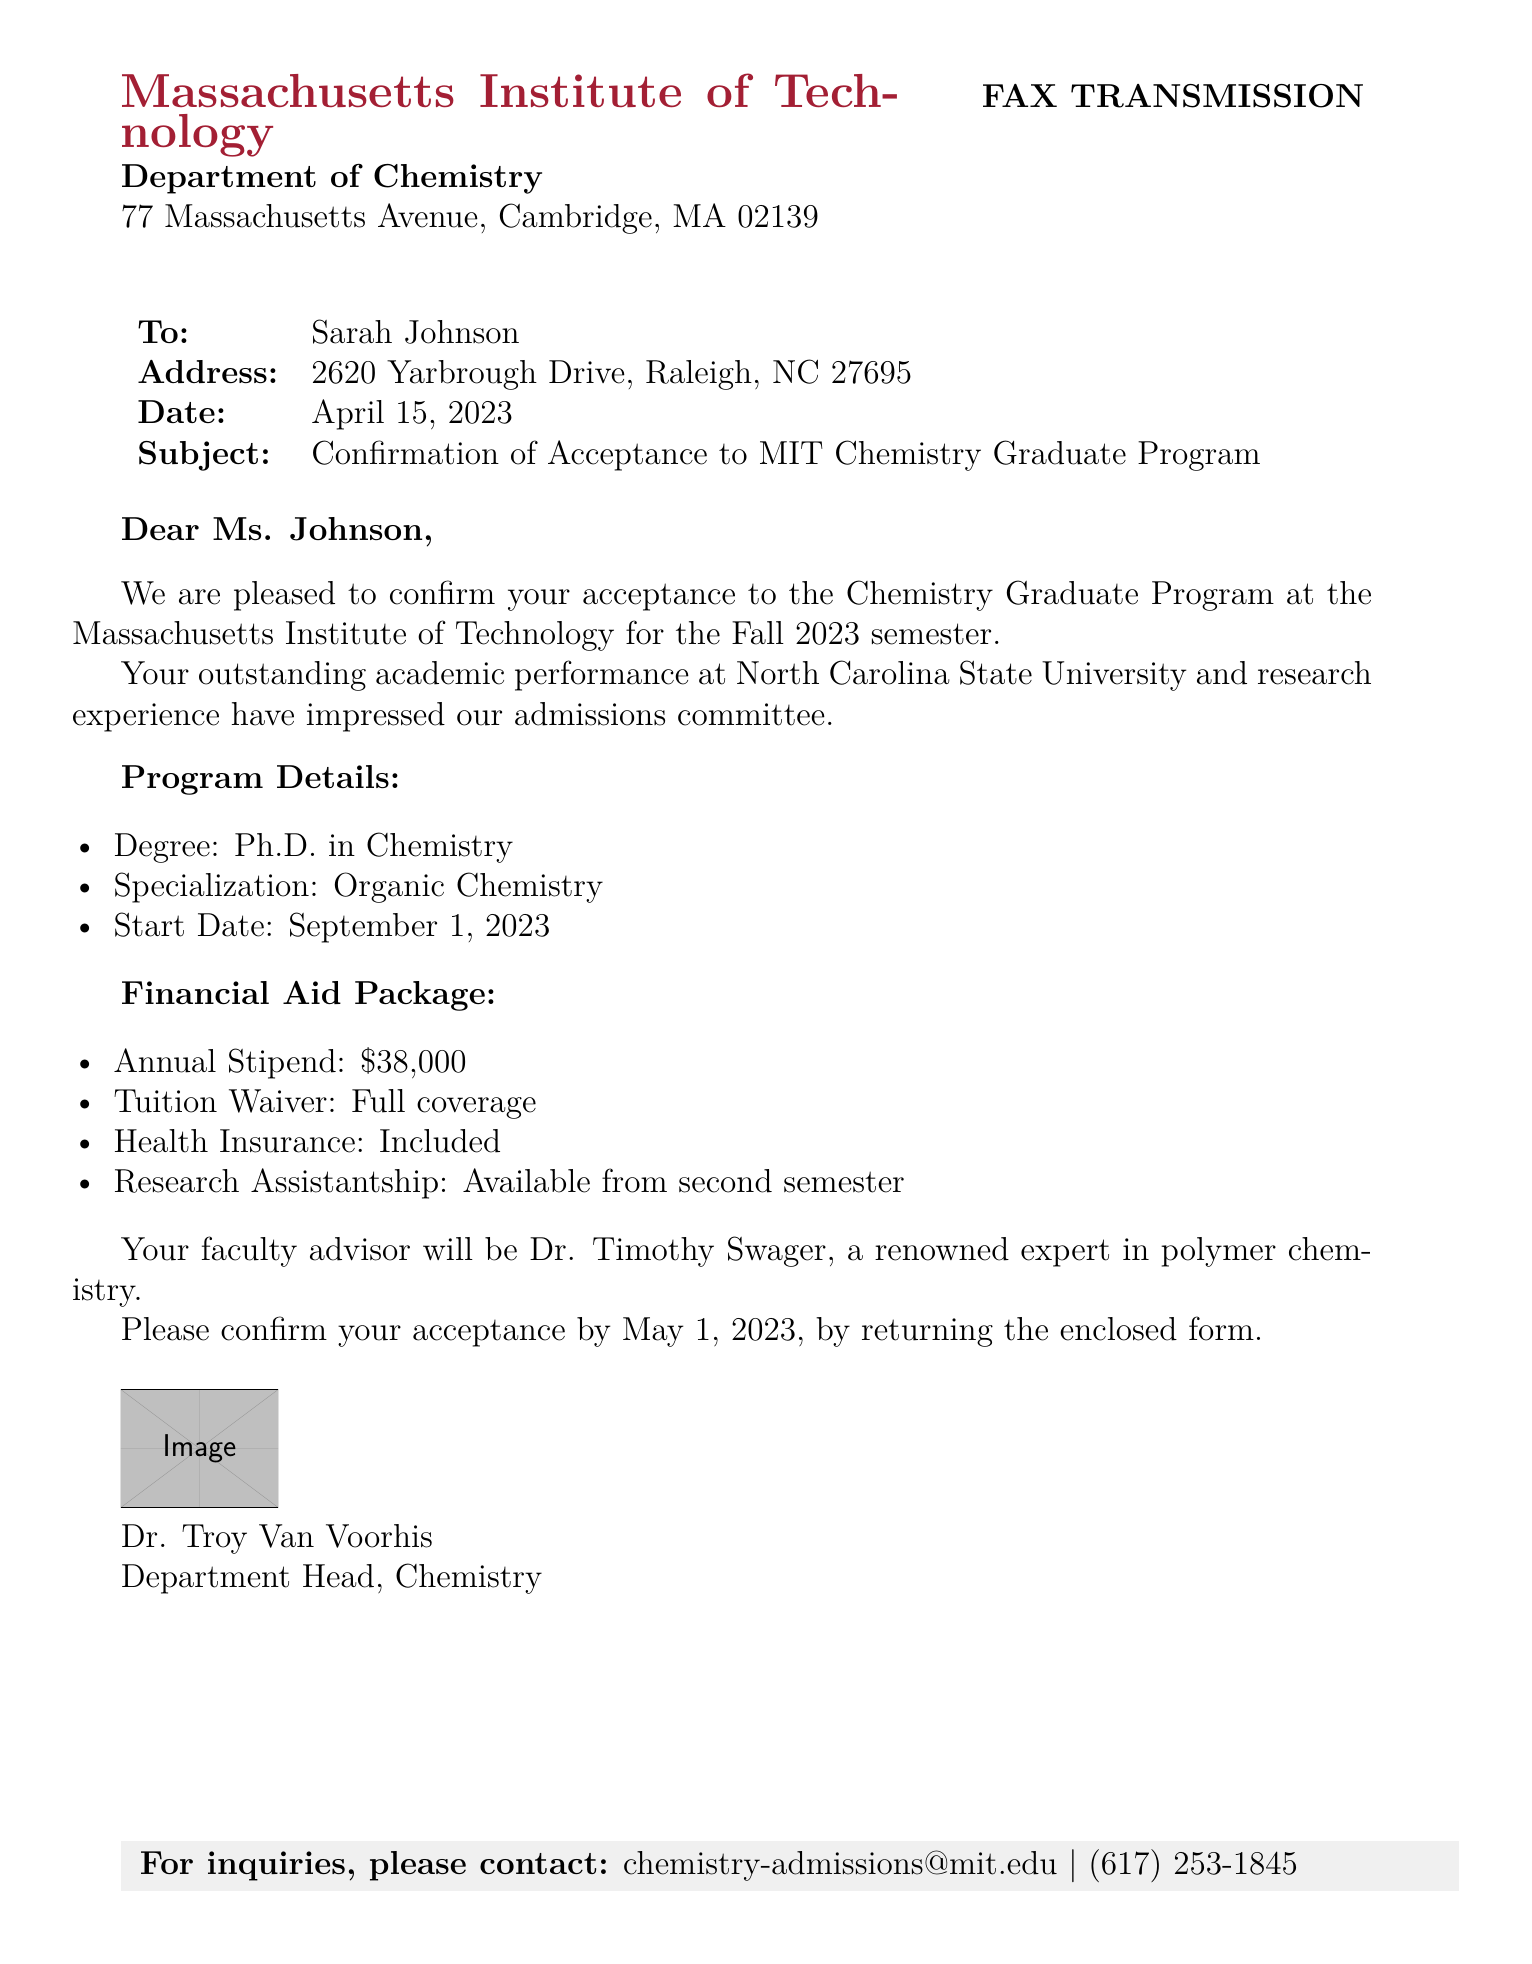What is the name of the recipient? The recipient's name is mentioned in the salutation line of the document as Ms. Johnson.
Answer: Sarah Johnson What is the date of the fax? The date of the fax is clearly stated in the document's header under the date section.
Answer: April 15, 2023 What is the degree offered? The degree is specified in the program details section of the document.
Answer: Ph.D. in Chemistry What is the annual stipend amount? The annual stipend is detailed in the financial aid package section.
Answer: $38,000 Who is the faculty advisor? The faculty advisor is mentioned explicitly in the document, indicating the individual's expertise.
Answer: Dr. Timothy Swager What is the start date of the program? The start date is provided in the program details section of the document.
Answer: September 1, 2023 What type of financial aid is included? The financial aid package includes several components, as listed in the financial aid section.
Answer: Tuition Waiver: Full coverage By when should the acceptance be confirmed? The confirmation deadline is provided at the end of the document.
Answer: May 1, 2023 What is the subject of the fax? The subject line clearly states the main purpose of the fax document.
Answer: Confirmation of Acceptance to MIT Chemistry Graduate Program 